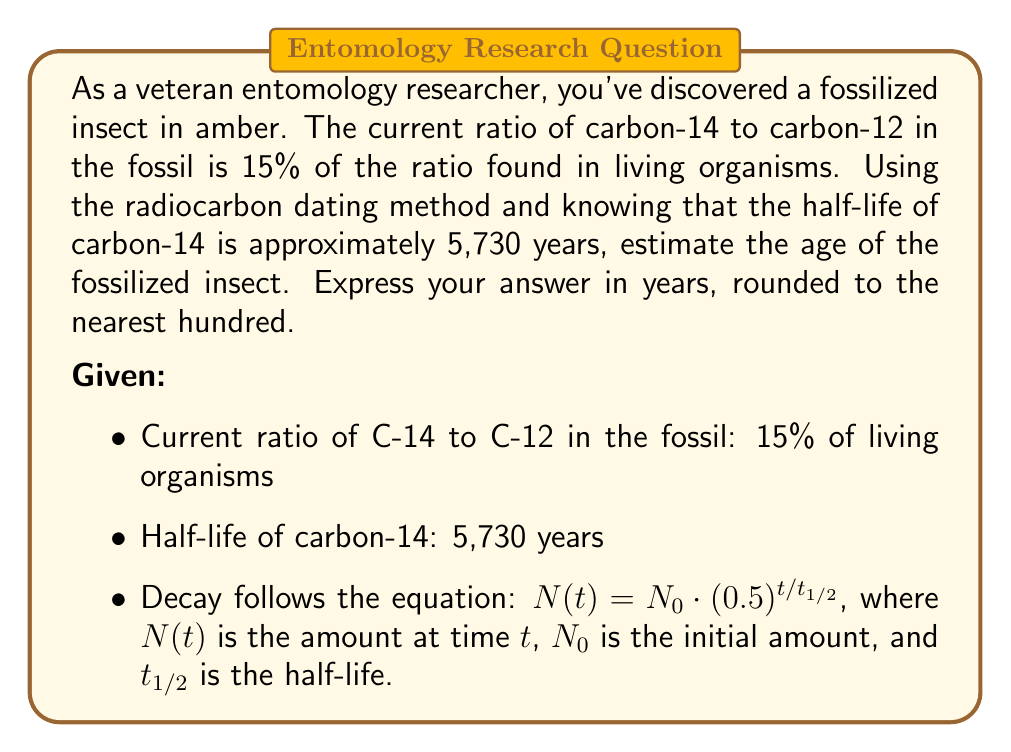Can you solve this math problem? To solve this problem, we'll use the radioactive decay equation and logarithms. Let's approach this step-by-step:

1) The decay equation is:
   $N(t) = N_0 \cdot (0.5)^{t/t_{1/2}}$

2) In our case:
   - $N(t)/N_0 = 0.15$ (current ratio is 15% of the original)
   - $t_{1/2} = 5,730$ years

3) Let's substitute these into the equation:
   $0.15 = (0.5)^{t/5730}$

4) To solve for $t$, we need to use logarithms. Let's take the natural log of both sides:
   $\ln(0.15) = \ln((0.5)^{t/5730})$

5) Using the logarithm property $\ln(a^b) = b\ln(a)$:
   $\ln(0.15) = (t/5730) \cdot \ln(0.5)$

6) Now we can solve for $t$:
   $t = 5730 \cdot \frac{\ln(0.15)}{\ln(0.5)}$

7) Let's calculate this:
   $t = 5730 \cdot \frac{-1.8971}{-0.6931} \approx 15,685.8$ years

8) Rounding to the nearest hundred:
   $t \approx 15,700$ years

Therefore, the estimated age of the fossilized insect is approximately 15,700 years.
Answer: 15,700 years 